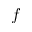Convert formula to latex. <formula><loc_0><loc_0><loc_500><loc_500>f</formula> 